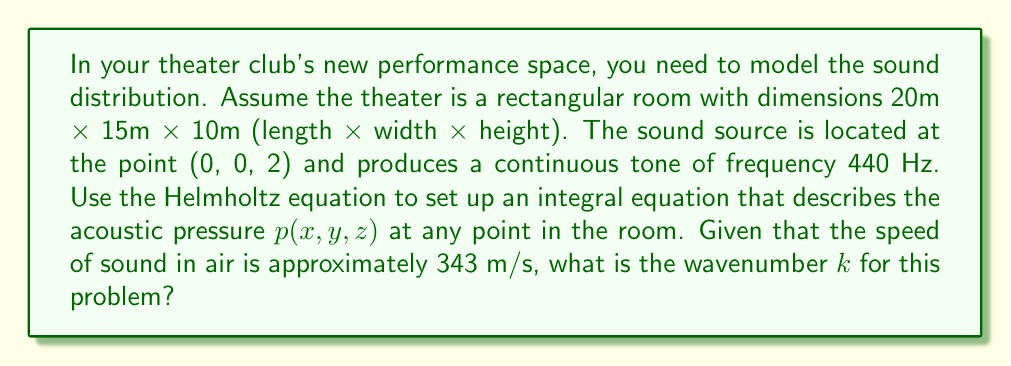Can you solve this math problem? Let's approach this step-by-step:

1) The Helmholtz equation for time-harmonic acoustic waves is:

   $$\nabla^2 p + k^2 p = 0$$

   where $p$ is the acoustic pressure and $k$ is the wavenumber.

2) To set up an integral equation, we use Green's function $G(r,r')$, which satisfies:

   $$\nabla^2 G + k^2 G = -\delta(r-r')$$

   where $\delta$ is the Dirac delta function, $r$ is the observation point, and $r'$ is the source point.

3) The integral equation for the acoustic pressure is:

   $$p(r) = \int_V G(r,r')f(r')dV' + \oint_S \left(G(r,r')\frac{\partial p(r')}{\partial n'} - p(r')\frac{\partial G(r,r')}{\partial n'}\right)dS'$$

   where $V$ is the volume of the room, $S$ is its surface, and $f(r')$ is the source term.

4) In this case, the source is a point source at (0, 0, 2), so $f(r') = \delta(x')\delta(y')\delta(z'-2)$.

5) The wavenumber $k$ is related to the frequency $f$ and speed of sound $c$ by:

   $$k = \frac{2\pi f}{c}$$

6) Given:
   - Frequency $f = 440$ Hz
   - Speed of sound $c = 343$ m/s

7) Calculating $k$:

   $$k = \frac{2\pi \cdot 440}{343} \approx 8.0596 \text{ m}^{-1}$$
Answer: $k \approx 8.0596 \text{ m}^{-1}$ 